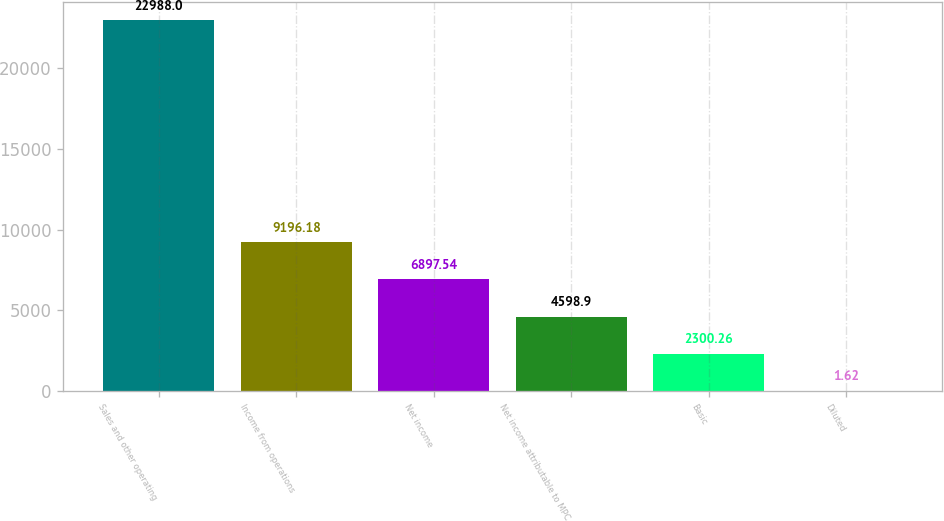Convert chart to OTSL. <chart><loc_0><loc_0><loc_500><loc_500><bar_chart><fcel>Sales and other operating<fcel>Income from operations<fcel>Net income<fcel>Net income attributable to MPC<fcel>Basic<fcel>Diluted<nl><fcel>22988<fcel>9196.18<fcel>6897.54<fcel>4598.9<fcel>2300.26<fcel>1.62<nl></chart> 